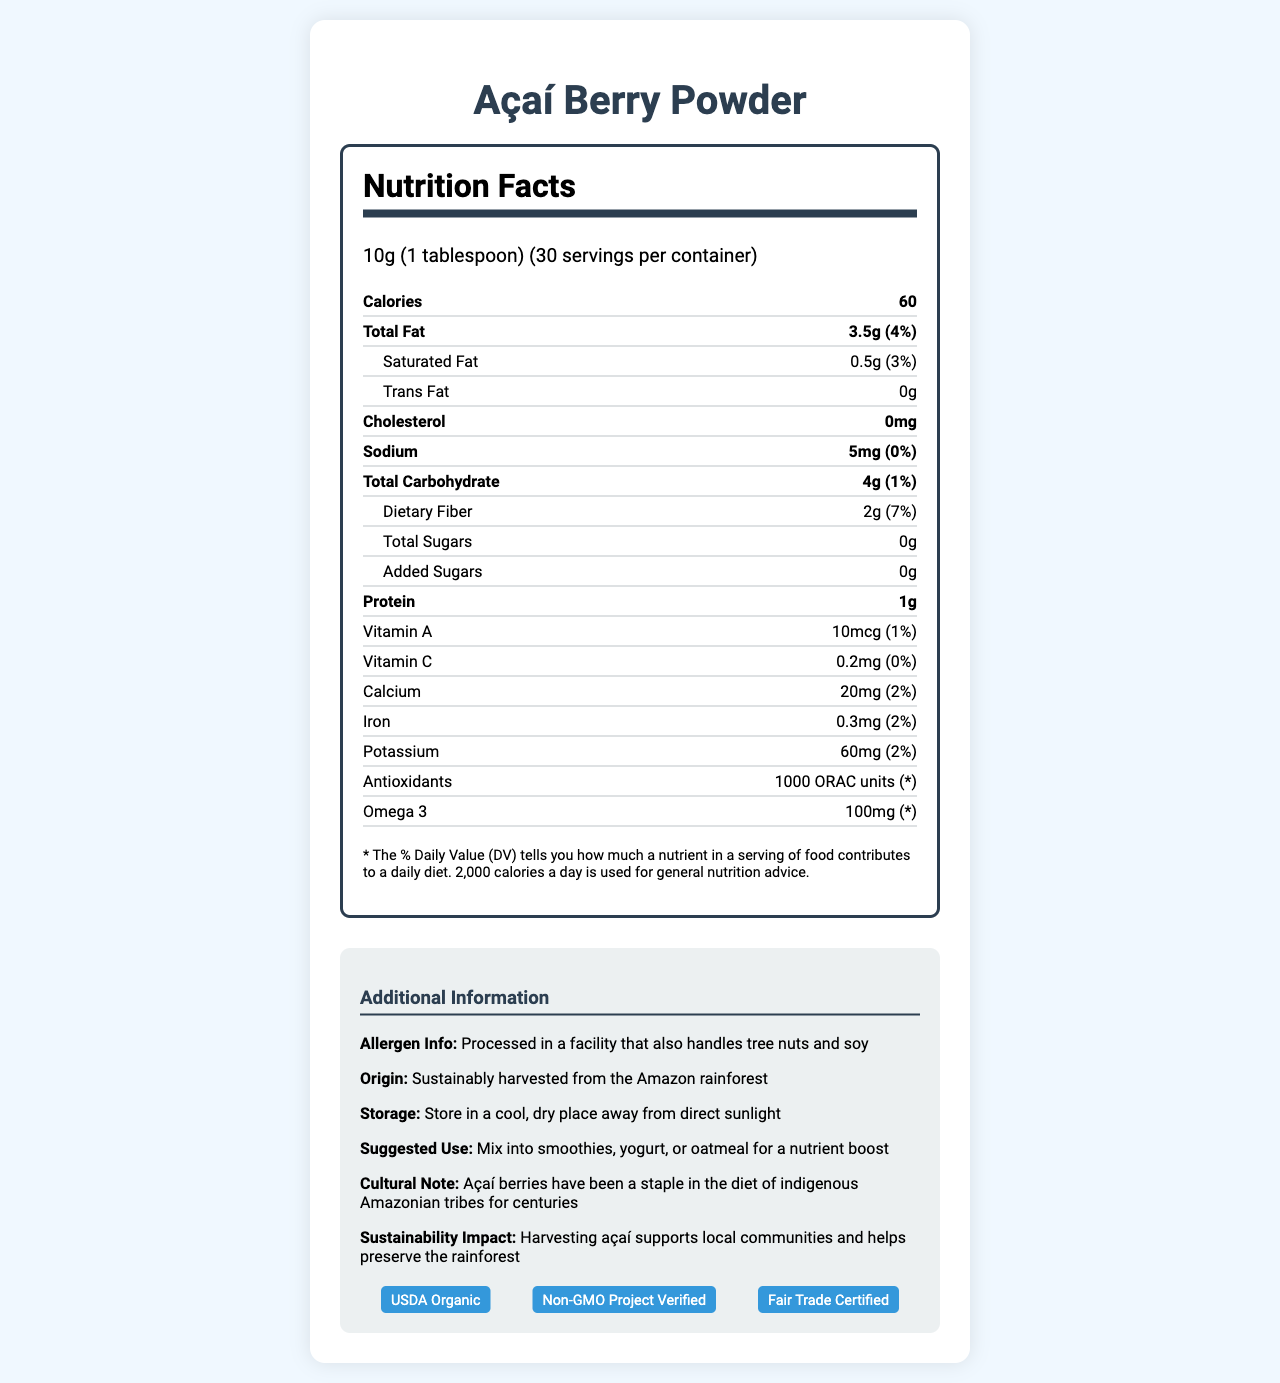what is the serving size? The document lists the serving size as 10g (1 tablespoon) in the nutrition facts section.
Answer: 10g (1 tablespoon) how many calories are in one serving? The document lists 60 calories per serving in the nutrition facts section.
Answer: 60 what is the percentage daily value of total fat in one serving? The document lists the total fat as 3.5g with a daily value of 4%.
Answer: 4% how much dietary fiber is in one serving? The document states that there are 2g of dietary fiber in one serving.
Answer: 2g where is the açaí berry powder sourced from? The document mentions the origin of the açaí berry powder as being sustainably harvested from the Amazon rainforest in the additional information section.
Answer: Sustainably harvested from the Amazon rainforest which of the following certifications does the açaí berry powder have? A. USDA Organic B. Non-GMO Project Verified C. Gluten-Free D. Fair Trade Certified The document lists the certifications as USDA Organic, Non-GMO Project Verified, and Fair Trade Certified.
Answer: A, B, D what is the daily value percentage of calcium in one serving? A. 1% B. 2% C. 3% D. 4% The document states that one serving contains 20mg of calcium, which is 2% of the daily value.
Answer: B does the product contain any cholesterol? The document specifies that there is 0mg of cholesterol per serving.
Answer: No is the product processed in a facility that handles tree nuts and soy? The document contains an allergen information section which states that the product is processed in a facility that handles tree nuts and soy.
Answer: Yes describe the main idea of the document. This answer is derived from a summary analysis of the entire document, focusing on the key information provided about the Açaí Berry Powder.
Answer: The document provides the nutritional information for Açaí Berry Powder, highlighting its serving size, calories, fat, cholesterol, sodium, carbohydrate, protein content, and various vitamins and minerals. Additionally, it details allergen information, origin, storage instructions, suggested use, cultural significance, and sustainability impact. Certifications are also highlighted. what is the ORAC unit value of antioxidants in one serving? The document lists the antioxidant content as 1000 ORAC units under the nutrition facts.
Answer: 1000 ORAC units does the product contain any added sugars? The document states that there are 0g of added sugars per serving.
Answer: No how does the suggested use recommend using the açaí berry powder? The document suggests using the açaí berry powder by mixing it into smoothies, yogurt, or oatmeal for a nutrient boost, as stated in the additional information section.
Answer: Mix into smoothies, yogurt, or oatmeal for a nutrient boost what are the geographical implications mentioned regarding the product? The document mentions that the sustainability impact of harvesting açaí helps support local communities and preserve the rainforest.
Answer: Harvesting açaí supports local communities and helps preserve the rainforest. how much potassium is in one serving of the açaí berry powder? The document indicates that there are 60mg of potassium per serving.
Answer: 60mg what is the purpose of the footnote included in the nutrition facts section? The footnote explains that the daily value percentage tells you how much a nutrient in a serving of food contributes to a daily diet based on a 2,000-calorie diet.
Answer: To explain the daily value percentage 